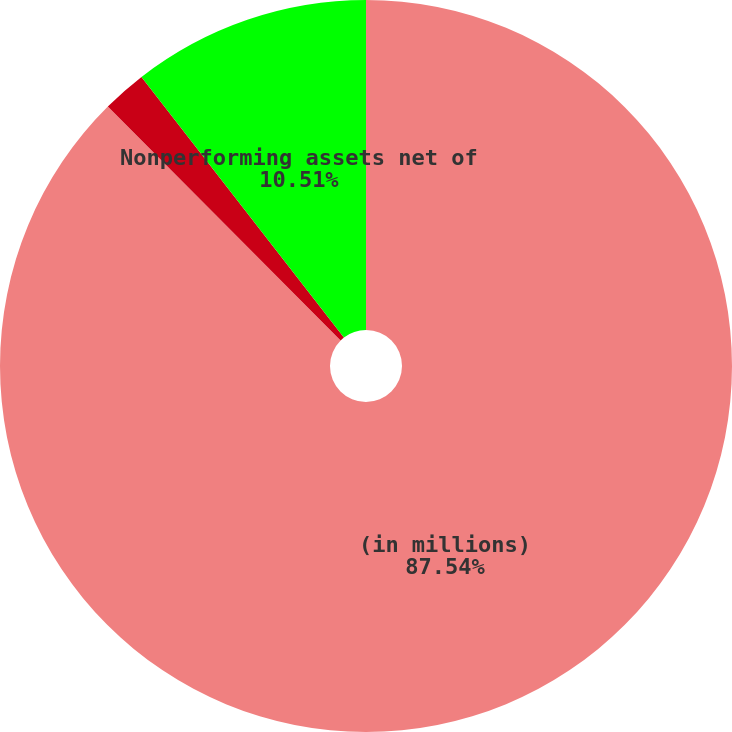<chart> <loc_0><loc_0><loc_500><loc_500><pie_chart><fcel>(in millions)<fcel>Retail<fcel>Nonperforming assets net of<nl><fcel>87.53%<fcel>1.95%<fcel>10.51%<nl></chart> 